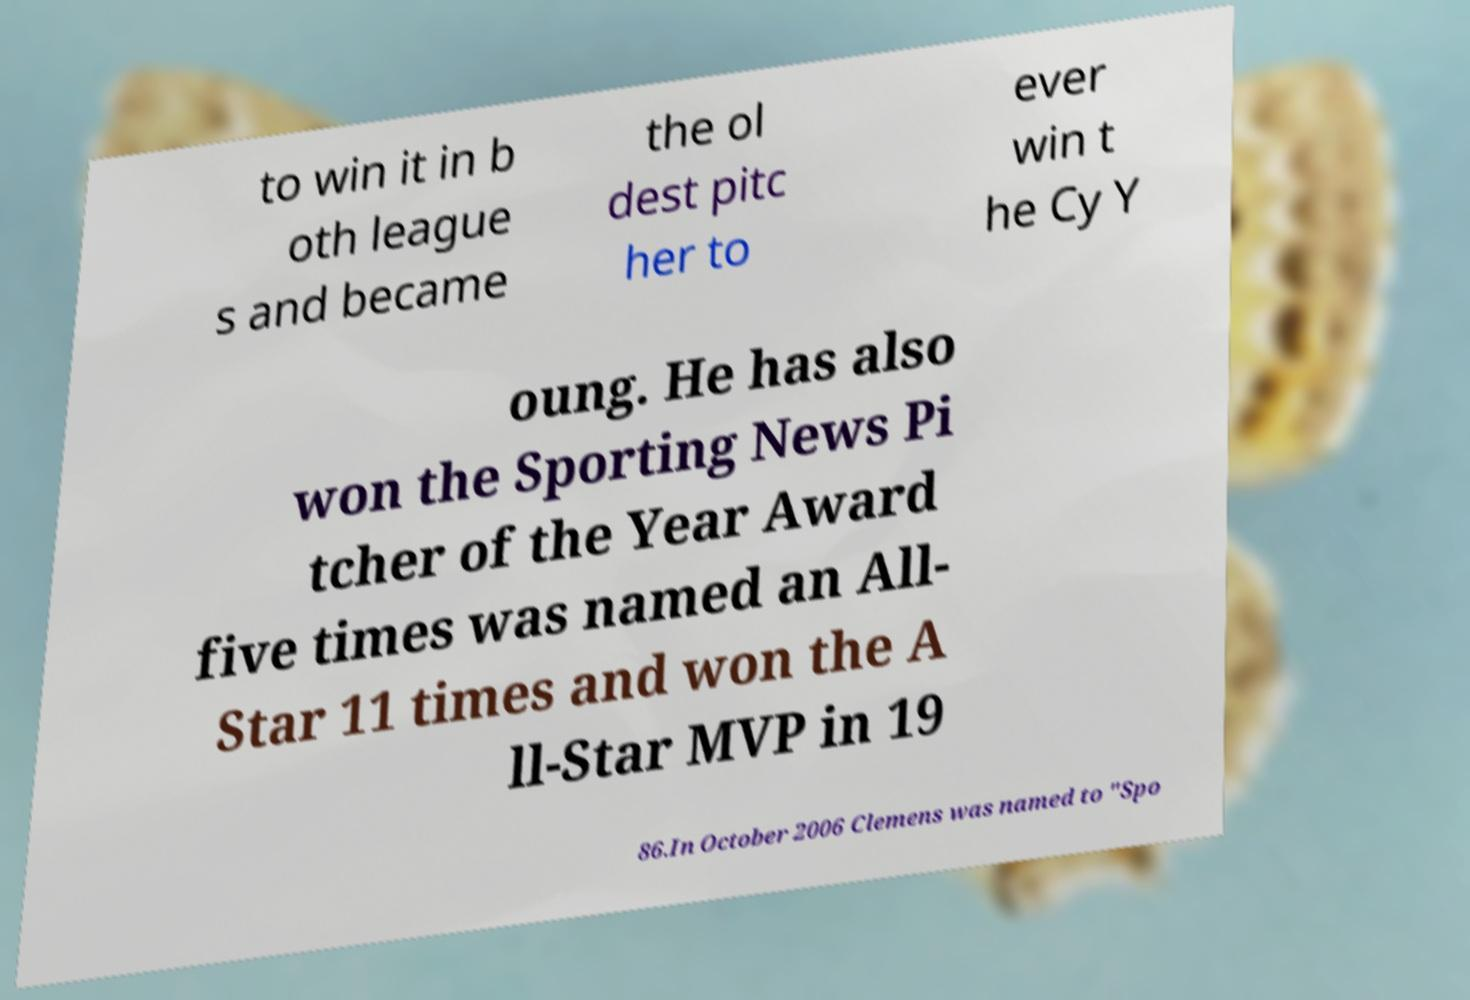Please identify and transcribe the text found in this image. to win it in b oth league s and became the ol dest pitc her to ever win t he Cy Y oung. He has also won the Sporting News Pi tcher of the Year Award five times was named an All- Star 11 times and won the A ll-Star MVP in 19 86.In October 2006 Clemens was named to "Spo 